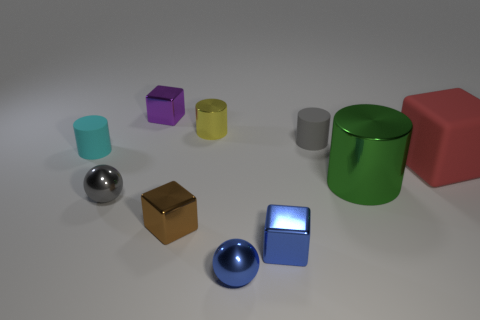Subtract all yellow shiny cylinders. How many cylinders are left? 3 Subtract all brown cubes. How many cubes are left? 3 Subtract 1 cylinders. How many cylinders are left? 3 Subtract all balls. How many objects are left? 8 Add 9 small blue blocks. How many small blue blocks are left? 10 Add 8 red matte things. How many red matte things exist? 9 Subtract 0 purple cylinders. How many objects are left? 10 Subtract all gray balls. Subtract all green cylinders. How many balls are left? 1 Subtract all tiny brown things. Subtract all purple metal cubes. How many objects are left? 8 